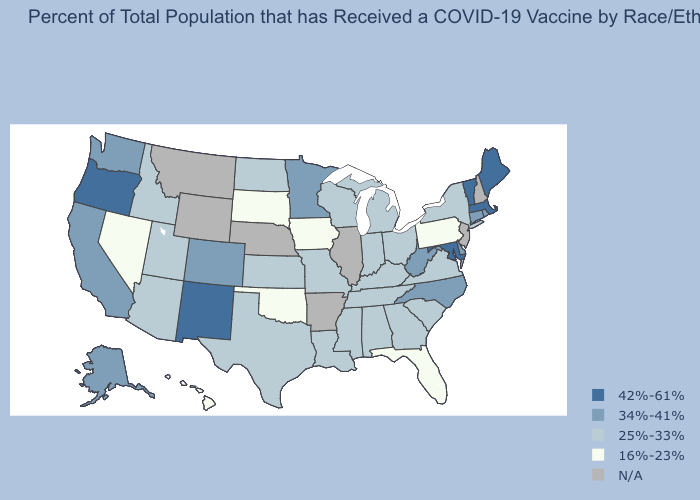Does Massachusetts have the highest value in the Northeast?
Keep it brief. Yes. What is the value of Montana?
Answer briefly. N/A. Name the states that have a value in the range 42%-61%?
Short answer required. Maine, Maryland, Massachusetts, New Mexico, Oregon, Vermont. What is the value of Oklahoma?
Answer briefly. 16%-23%. Name the states that have a value in the range 34%-41%?
Short answer required. Alaska, California, Colorado, Connecticut, Delaware, Minnesota, North Carolina, Rhode Island, Washington, West Virginia. Name the states that have a value in the range 25%-33%?
Quick response, please. Alabama, Arizona, Georgia, Idaho, Indiana, Kansas, Kentucky, Louisiana, Michigan, Mississippi, Missouri, New York, North Dakota, Ohio, South Carolina, Tennessee, Texas, Utah, Virginia, Wisconsin. Name the states that have a value in the range 16%-23%?
Write a very short answer. Florida, Hawaii, Iowa, Nevada, Oklahoma, Pennsylvania, South Dakota. Name the states that have a value in the range 25%-33%?
Write a very short answer. Alabama, Arizona, Georgia, Idaho, Indiana, Kansas, Kentucky, Louisiana, Michigan, Mississippi, Missouri, New York, North Dakota, Ohio, South Carolina, Tennessee, Texas, Utah, Virginia, Wisconsin. Which states have the highest value in the USA?
Write a very short answer. Maine, Maryland, Massachusetts, New Mexico, Oregon, Vermont. What is the value of Tennessee?
Write a very short answer. 25%-33%. Does Massachusetts have the highest value in the USA?
Quick response, please. Yes. What is the highest value in the USA?
Give a very brief answer. 42%-61%. Is the legend a continuous bar?
Concise answer only. No. What is the value of South Carolina?
Quick response, please. 25%-33%. 